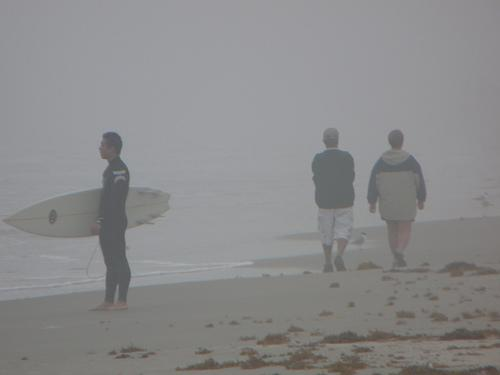Describe the state of the beach and the presence of any objects or animals.  The beach is wet and dense with washed-up seaweed, and there is a bird by the water's edge. What are the couple walking on the beach wearing, and provide a detail about the man's appearance? The woman is wearing a black and tan jacket while the man has white shorts and short black hair. What kind of weather is in the image, and what can you tell about the ocean? There is foggy and cloudy weather, and the ocean appears calm and dark with wet and dense sand on the beach. Identify the main activity taking place in the image, and mention the type of location it is happening. Surfers are on a foggy beach as the main activity, with one standing on the wet sand holding a surfboard, looking at the ocean. How many different objects or elements in the image, excluding human subjects, are explicitly mentioned within the information provided? There are 8 objects mentioned: surfboard (white, with logo, and tip), jacket, shorts, the beach, seaweed, ocean, bird, and sky. What sentiment or mood does the image evoke, considering the weather conditions and the people's actions? The image evokes a serene and peaceful mood, as people engage in beach activities despite the foggy and cloudy conditions. Comment on the footwear choice of the surfer wearing the wetsuit. The surfer is barefoot while wearing the black wetsuit. Based on the image's content, would you say it is an ideal day for surfing or beach activities? Explain. It might not be ideal due to the foggy and cloudy weather, along with calm ocean water and the presence of seaweed on the beach. How many people are in the image, and what are they respectively doing? There are three people - a surfer standing on the shore holding a surfboard, a man looking at the ocean, and a couple walking on the beach. Mention the key attributes about the wet suit and surfboard the surfer is carrying. The surfer is wearing a black wetsuit with a white logo and carrying a white surfboard with a logo on it. Is the surfer wearing a blue wetsuit? No, it's not mentioned in the image. 